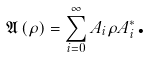Convert formula to latex. <formula><loc_0><loc_0><loc_500><loc_500>\mathfrak { A } \left ( \rho \right ) = \sum _ { i = 0 } ^ { \infty } A _ { i } \rho A _ { i } ^ { \ast } \text {.}</formula> 